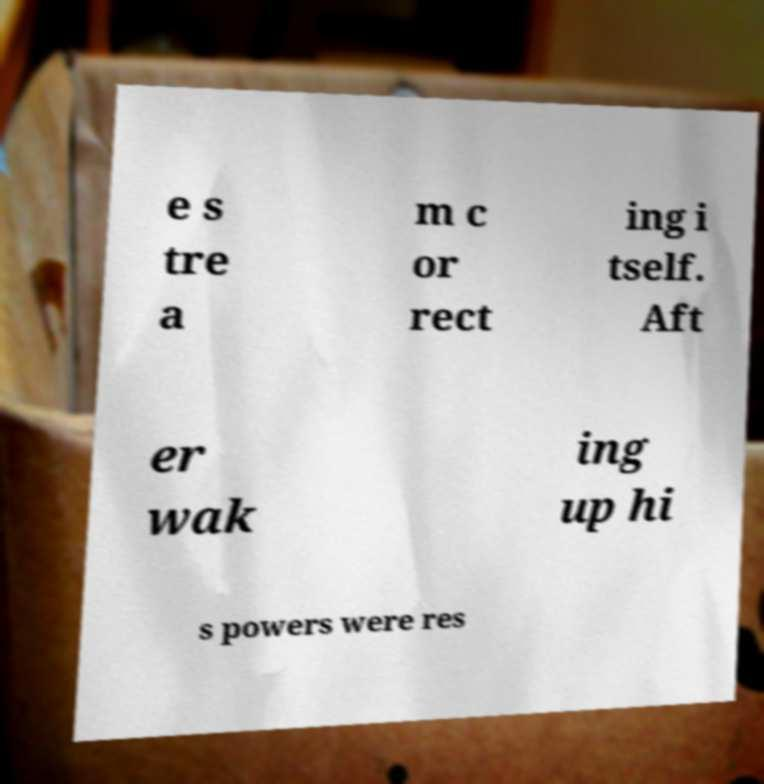What messages or text are displayed in this image? I need them in a readable, typed format. e s tre a m c or rect ing i tself. Aft er wak ing up hi s powers were res 